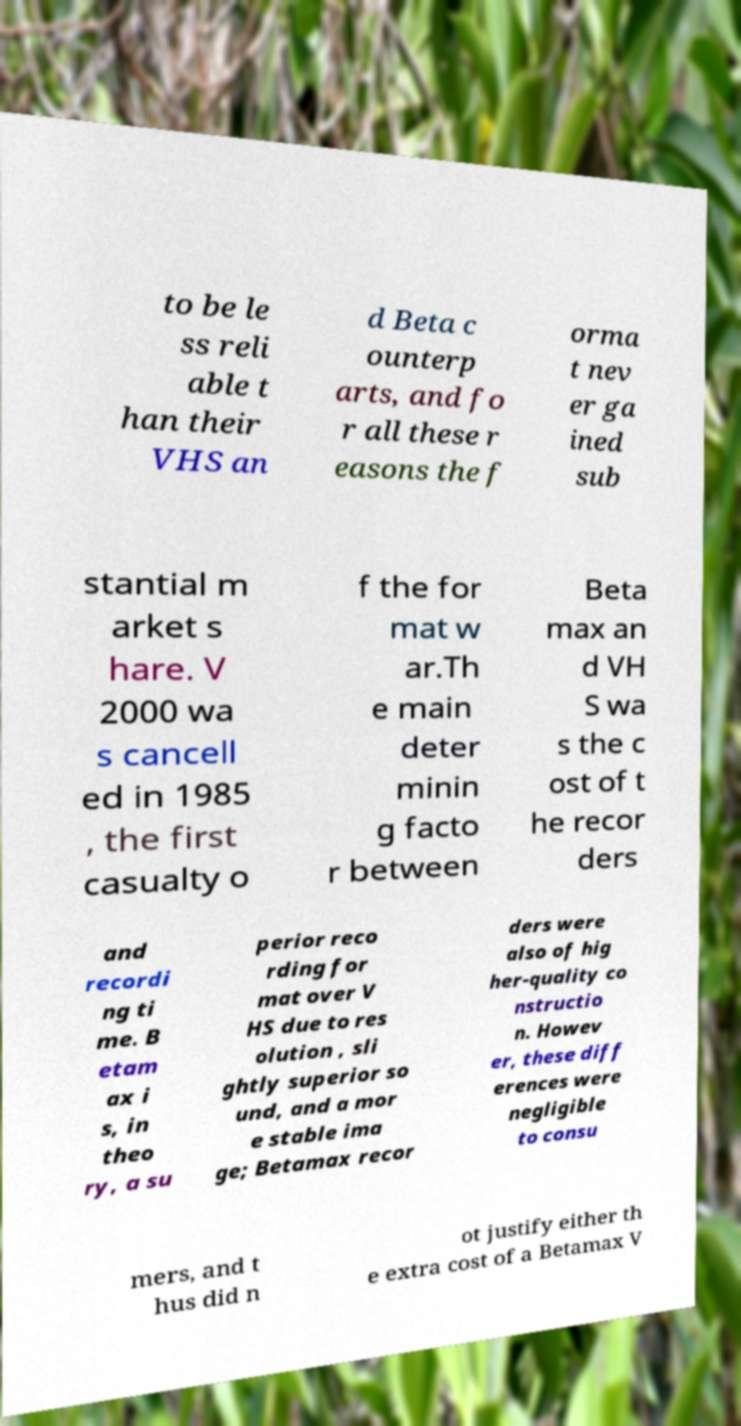I need the written content from this picture converted into text. Can you do that? to be le ss reli able t han their VHS an d Beta c ounterp arts, and fo r all these r easons the f orma t nev er ga ined sub stantial m arket s hare. V 2000 wa s cancell ed in 1985 , the first casualty o f the for mat w ar.Th e main deter minin g facto r between Beta max an d VH S wa s the c ost of t he recor ders and recordi ng ti me. B etam ax i s, in theo ry, a su perior reco rding for mat over V HS due to res olution , sli ghtly superior so und, and a mor e stable ima ge; Betamax recor ders were also of hig her-quality co nstructio n. Howev er, these diff erences were negligible to consu mers, and t hus did n ot justify either th e extra cost of a Betamax V 